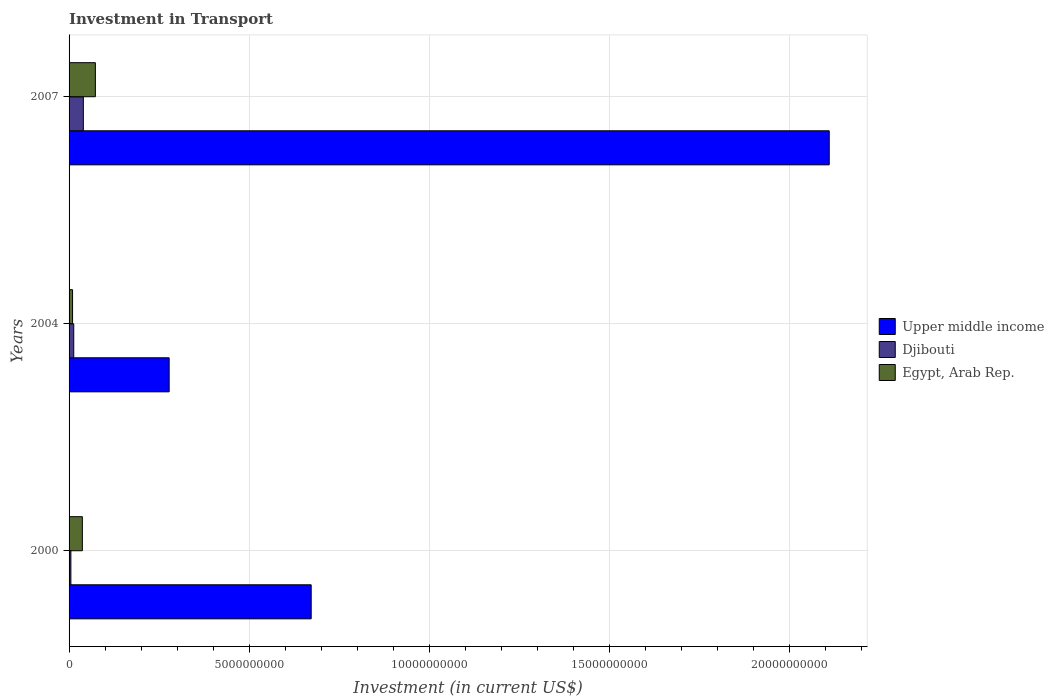How many different coloured bars are there?
Your response must be concise. 3. How many groups of bars are there?
Give a very brief answer. 3. Are the number of bars per tick equal to the number of legend labels?
Your answer should be very brief. Yes. Are the number of bars on each tick of the Y-axis equal?
Provide a short and direct response. Yes. How many bars are there on the 2nd tick from the top?
Provide a succinct answer. 3. How many bars are there on the 2nd tick from the bottom?
Provide a succinct answer. 3. In how many cases, is the number of bars for a given year not equal to the number of legend labels?
Your answer should be compact. 0. What is the amount invested in transport in Egypt, Arab Rep. in 2000?
Ensure brevity in your answer.  3.68e+08. Across all years, what is the maximum amount invested in transport in Djibouti?
Your answer should be very brief. 3.96e+08. Across all years, what is the minimum amount invested in transport in Egypt, Arab Rep.?
Provide a succinct answer. 9.70e+07. In which year was the amount invested in transport in Djibouti minimum?
Provide a short and direct response. 2000. What is the total amount invested in transport in Upper middle income in the graph?
Your response must be concise. 3.06e+1. What is the difference between the amount invested in transport in Egypt, Arab Rep. in 2004 and that in 2007?
Keep it short and to the point. -6.33e+08. What is the difference between the amount invested in transport in Egypt, Arab Rep. in 2004 and the amount invested in transport in Upper middle income in 2000?
Provide a succinct answer. -6.62e+09. What is the average amount invested in transport in Djibouti per year?
Give a very brief answer. 1.92e+08. In the year 2004, what is the difference between the amount invested in transport in Upper middle income and amount invested in transport in Egypt, Arab Rep.?
Provide a succinct answer. 2.68e+09. In how many years, is the amount invested in transport in Djibouti greater than 5000000000 US$?
Your answer should be compact. 0. What is the ratio of the amount invested in transport in Upper middle income in 2004 to that in 2007?
Make the answer very short. 0.13. Is the difference between the amount invested in transport in Upper middle income in 2000 and 2007 greater than the difference between the amount invested in transport in Egypt, Arab Rep. in 2000 and 2007?
Offer a terse response. No. What is the difference between the highest and the second highest amount invested in transport in Upper middle income?
Provide a succinct answer. 1.44e+1. What is the difference between the highest and the lowest amount invested in transport in Upper middle income?
Keep it short and to the point. 1.83e+1. In how many years, is the amount invested in transport in Djibouti greater than the average amount invested in transport in Djibouti taken over all years?
Offer a very short reply. 1. Is the sum of the amount invested in transport in Upper middle income in 2000 and 2007 greater than the maximum amount invested in transport in Djibouti across all years?
Your answer should be very brief. Yes. What does the 3rd bar from the top in 2004 represents?
Offer a very short reply. Upper middle income. What does the 3rd bar from the bottom in 2007 represents?
Ensure brevity in your answer.  Egypt, Arab Rep. Is it the case that in every year, the sum of the amount invested in transport in Djibouti and amount invested in transport in Upper middle income is greater than the amount invested in transport in Egypt, Arab Rep.?
Your answer should be compact. Yes. How many bars are there?
Your answer should be compact. 9. Are all the bars in the graph horizontal?
Keep it short and to the point. Yes. What is the difference between two consecutive major ticks on the X-axis?
Your answer should be compact. 5.00e+09. Are the values on the major ticks of X-axis written in scientific E-notation?
Keep it short and to the point. No. Where does the legend appear in the graph?
Ensure brevity in your answer.  Center right. How many legend labels are there?
Offer a terse response. 3. How are the legend labels stacked?
Ensure brevity in your answer.  Vertical. What is the title of the graph?
Make the answer very short. Investment in Transport. Does "South Asia" appear as one of the legend labels in the graph?
Provide a succinct answer. No. What is the label or title of the X-axis?
Provide a succinct answer. Investment (in current US$). What is the Investment (in current US$) in Upper middle income in 2000?
Offer a very short reply. 6.72e+09. What is the Investment (in current US$) in Egypt, Arab Rep. in 2000?
Provide a succinct answer. 3.68e+08. What is the Investment (in current US$) in Upper middle income in 2004?
Offer a very short reply. 2.78e+09. What is the Investment (in current US$) in Djibouti in 2004?
Keep it short and to the point. 1.30e+08. What is the Investment (in current US$) in Egypt, Arab Rep. in 2004?
Your response must be concise. 9.70e+07. What is the Investment (in current US$) of Upper middle income in 2007?
Offer a terse response. 2.11e+1. What is the Investment (in current US$) in Djibouti in 2007?
Offer a very short reply. 3.96e+08. What is the Investment (in current US$) of Egypt, Arab Rep. in 2007?
Give a very brief answer. 7.30e+08. Across all years, what is the maximum Investment (in current US$) of Upper middle income?
Keep it short and to the point. 2.11e+1. Across all years, what is the maximum Investment (in current US$) in Djibouti?
Your answer should be very brief. 3.96e+08. Across all years, what is the maximum Investment (in current US$) in Egypt, Arab Rep.?
Offer a terse response. 7.30e+08. Across all years, what is the minimum Investment (in current US$) in Upper middle income?
Keep it short and to the point. 2.78e+09. Across all years, what is the minimum Investment (in current US$) of Egypt, Arab Rep.?
Offer a very short reply. 9.70e+07. What is the total Investment (in current US$) in Upper middle income in the graph?
Provide a short and direct response. 3.06e+1. What is the total Investment (in current US$) in Djibouti in the graph?
Your response must be concise. 5.76e+08. What is the total Investment (in current US$) in Egypt, Arab Rep. in the graph?
Give a very brief answer. 1.20e+09. What is the difference between the Investment (in current US$) of Upper middle income in 2000 and that in 2004?
Offer a terse response. 3.94e+09. What is the difference between the Investment (in current US$) of Djibouti in 2000 and that in 2004?
Your response must be concise. -8.00e+07. What is the difference between the Investment (in current US$) of Egypt, Arab Rep. in 2000 and that in 2004?
Keep it short and to the point. 2.71e+08. What is the difference between the Investment (in current US$) in Upper middle income in 2000 and that in 2007?
Keep it short and to the point. -1.44e+1. What is the difference between the Investment (in current US$) of Djibouti in 2000 and that in 2007?
Offer a terse response. -3.46e+08. What is the difference between the Investment (in current US$) in Egypt, Arab Rep. in 2000 and that in 2007?
Offer a very short reply. -3.62e+08. What is the difference between the Investment (in current US$) in Upper middle income in 2004 and that in 2007?
Provide a succinct answer. -1.83e+1. What is the difference between the Investment (in current US$) in Djibouti in 2004 and that in 2007?
Make the answer very short. -2.66e+08. What is the difference between the Investment (in current US$) in Egypt, Arab Rep. in 2004 and that in 2007?
Your answer should be very brief. -6.33e+08. What is the difference between the Investment (in current US$) in Upper middle income in 2000 and the Investment (in current US$) in Djibouti in 2004?
Provide a short and direct response. 6.59e+09. What is the difference between the Investment (in current US$) of Upper middle income in 2000 and the Investment (in current US$) of Egypt, Arab Rep. in 2004?
Your answer should be very brief. 6.62e+09. What is the difference between the Investment (in current US$) in Djibouti in 2000 and the Investment (in current US$) in Egypt, Arab Rep. in 2004?
Offer a very short reply. -4.70e+07. What is the difference between the Investment (in current US$) of Upper middle income in 2000 and the Investment (in current US$) of Djibouti in 2007?
Give a very brief answer. 6.32e+09. What is the difference between the Investment (in current US$) of Upper middle income in 2000 and the Investment (in current US$) of Egypt, Arab Rep. in 2007?
Provide a succinct answer. 5.99e+09. What is the difference between the Investment (in current US$) of Djibouti in 2000 and the Investment (in current US$) of Egypt, Arab Rep. in 2007?
Ensure brevity in your answer.  -6.80e+08. What is the difference between the Investment (in current US$) in Upper middle income in 2004 and the Investment (in current US$) in Djibouti in 2007?
Offer a terse response. 2.38e+09. What is the difference between the Investment (in current US$) of Upper middle income in 2004 and the Investment (in current US$) of Egypt, Arab Rep. in 2007?
Provide a short and direct response. 2.05e+09. What is the difference between the Investment (in current US$) in Djibouti in 2004 and the Investment (in current US$) in Egypt, Arab Rep. in 2007?
Make the answer very short. -6.00e+08. What is the average Investment (in current US$) of Upper middle income per year?
Offer a terse response. 1.02e+1. What is the average Investment (in current US$) of Djibouti per year?
Offer a very short reply. 1.92e+08. What is the average Investment (in current US$) of Egypt, Arab Rep. per year?
Ensure brevity in your answer.  3.98e+08. In the year 2000, what is the difference between the Investment (in current US$) in Upper middle income and Investment (in current US$) in Djibouti?
Your response must be concise. 6.67e+09. In the year 2000, what is the difference between the Investment (in current US$) of Upper middle income and Investment (in current US$) of Egypt, Arab Rep.?
Give a very brief answer. 6.35e+09. In the year 2000, what is the difference between the Investment (in current US$) of Djibouti and Investment (in current US$) of Egypt, Arab Rep.?
Make the answer very short. -3.18e+08. In the year 2004, what is the difference between the Investment (in current US$) in Upper middle income and Investment (in current US$) in Djibouti?
Offer a very short reply. 2.65e+09. In the year 2004, what is the difference between the Investment (in current US$) in Upper middle income and Investment (in current US$) in Egypt, Arab Rep.?
Your answer should be very brief. 2.68e+09. In the year 2004, what is the difference between the Investment (in current US$) of Djibouti and Investment (in current US$) of Egypt, Arab Rep.?
Make the answer very short. 3.30e+07. In the year 2007, what is the difference between the Investment (in current US$) in Upper middle income and Investment (in current US$) in Djibouti?
Ensure brevity in your answer.  2.07e+1. In the year 2007, what is the difference between the Investment (in current US$) of Upper middle income and Investment (in current US$) of Egypt, Arab Rep.?
Offer a terse response. 2.04e+1. In the year 2007, what is the difference between the Investment (in current US$) in Djibouti and Investment (in current US$) in Egypt, Arab Rep.?
Ensure brevity in your answer.  -3.34e+08. What is the ratio of the Investment (in current US$) in Upper middle income in 2000 to that in 2004?
Ensure brevity in your answer.  2.42. What is the ratio of the Investment (in current US$) of Djibouti in 2000 to that in 2004?
Ensure brevity in your answer.  0.38. What is the ratio of the Investment (in current US$) of Egypt, Arab Rep. in 2000 to that in 2004?
Keep it short and to the point. 3.8. What is the ratio of the Investment (in current US$) of Upper middle income in 2000 to that in 2007?
Ensure brevity in your answer.  0.32. What is the ratio of the Investment (in current US$) of Djibouti in 2000 to that in 2007?
Ensure brevity in your answer.  0.13. What is the ratio of the Investment (in current US$) in Egypt, Arab Rep. in 2000 to that in 2007?
Ensure brevity in your answer.  0.5. What is the ratio of the Investment (in current US$) in Upper middle income in 2004 to that in 2007?
Provide a succinct answer. 0.13. What is the ratio of the Investment (in current US$) in Djibouti in 2004 to that in 2007?
Ensure brevity in your answer.  0.33. What is the ratio of the Investment (in current US$) of Egypt, Arab Rep. in 2004 to that in 2007?
Your answer should be very brief. 0.13. What is the difference between the highest and the second highest Investment (in current US$) in Upper middle income?
Offer a very short reply. 1.44e+1. What is the difference between the highest and the second highest Investment (in current US$) in Djibouti?
Ensure brevity in your answer.  2.66e+08. What is the difference between the highest and the second highest Investment (in current US$) in Egypt, Arab Rep.?
Your answer should be compact. 3.62e+08. What is the difference between the highest and the lowest Investment (in current US$) of Upper middle income?
Give a very brief answer. 1.83e+1. What is the difference between the highest and the lowest Investment (in current US$) of Djibouti?
Your answer should be compact. 3.46e+08. What is the difference between the highest and the lowest Investment (in current US$) of Egypt, Arab Rep.?
Keep it short and to the point. 6.33e+08. 